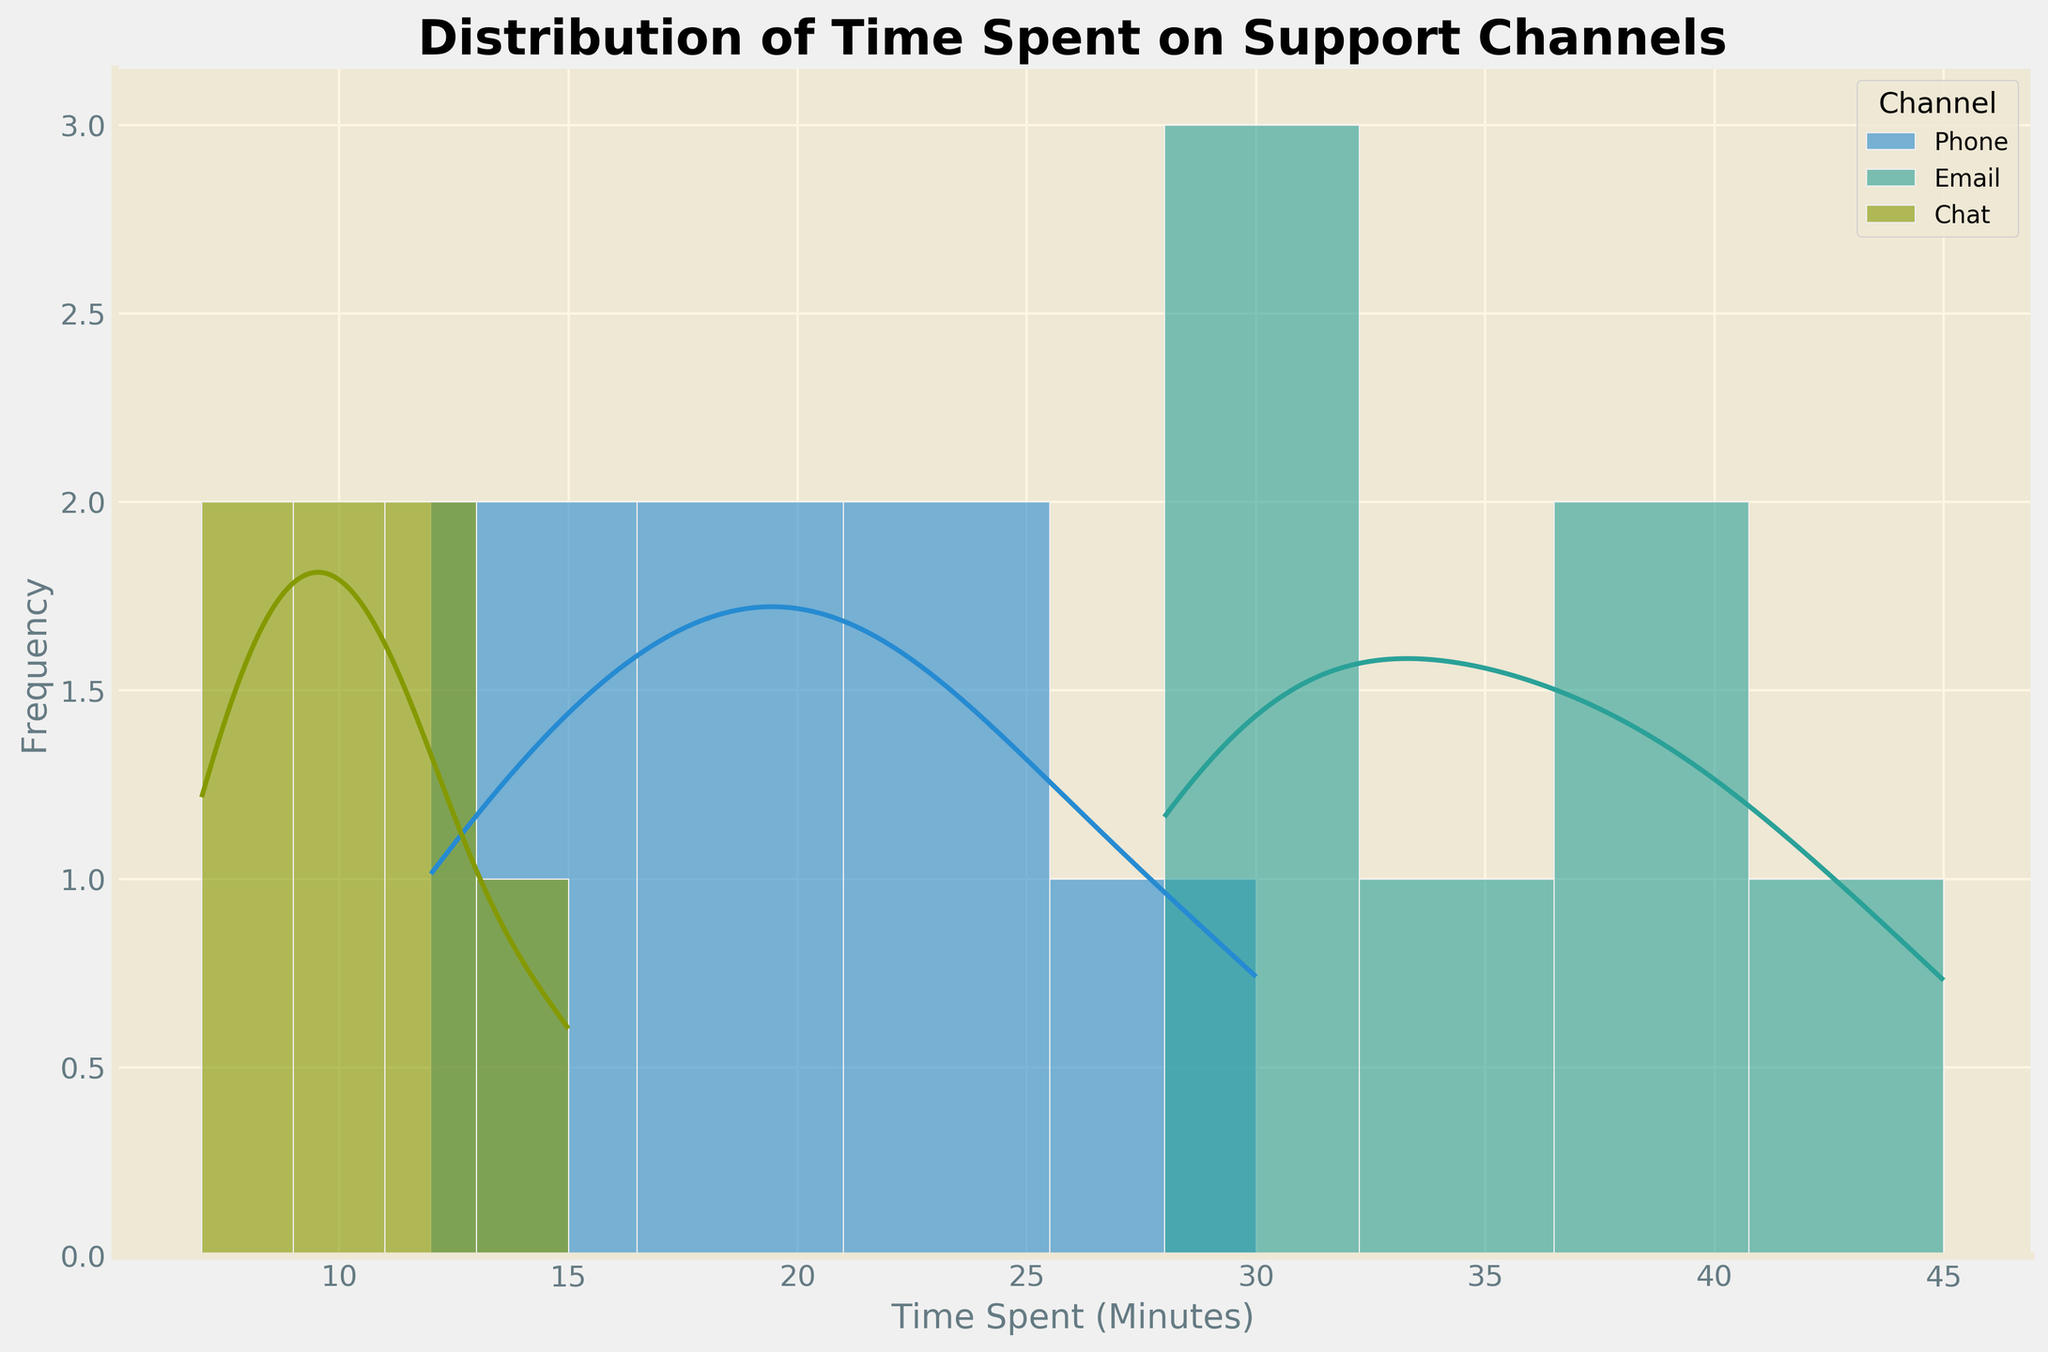How many channels are shown in the plot? The legend in the plot indicates there are multiple channels: Phone, Email, and Chat. Thus, by counting the distinct categories in the legend, we can determine the number of channels.
Answer: 3 What is the title of the plot? The title of the plot is typically shown at the top of the figure. According to the provided code, the title set with `ax.set_title` is 'Distribution of Time Spent on Support Channels'.
Answer: Distribution of Time Spent on Support Channels Which support channel has the widest spread in time spent? To determine the widest spread in time spent, we need to look at the range of the x-axis for each channel's histogram. The Email channel has a range roughly from 28 to 45, which is the widest among the three channels.
Answer: Email What is the average range where customers spend time on Phone support? By examining the histogram and KDE for the Phone channel, the time spent primarily falls within the range of 12 to 30 minutes. This can be observed as the main area where the data points are densely packed.
Answer: 12 to 30 minutes Which support channel has the highest peak in its density curve? By analyzing the peaks of the density curves (KDE) in the plot, the Chat channel has the highest peak, indicating it has the highest density of time spent within a narrow range.
Answer: Chat Is there any overlap in the time spent across different channels? By examining the histograms and KDEs, there are overlaps observed, particularly between the Phone and Chat channels in the range of around 12-20 minutes and between the Phone and Email around 30 minutes.
Answer: Yes Which support channel shows the least variability in time spent? The least variability is indicated by the narrowest spread of the time spent values. The Chat channel demonstrates the least variability with most values densely packed between 7 and 15 minutes.
Answer: Chat Which support channel has a time range reaching up to 40+ minutes? By examining the x-axis ranges of different channels, the Email channel extends up to and beyond 40 minutes, as indicated by the histogram and KDE plot.
Answer: Email 